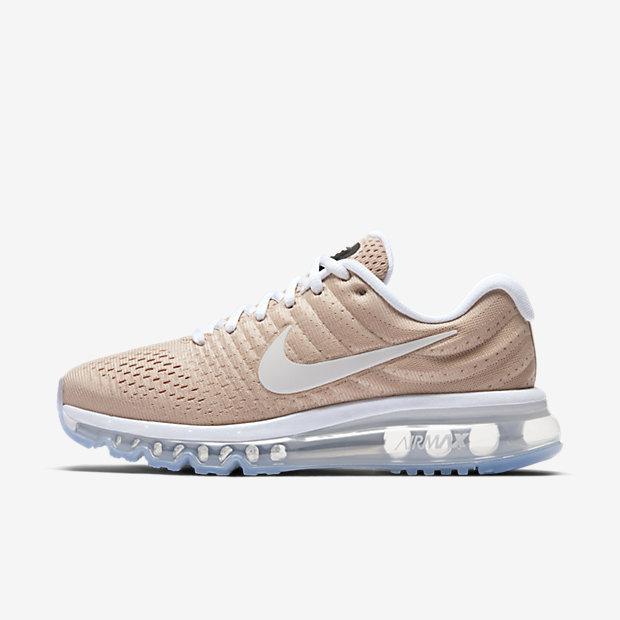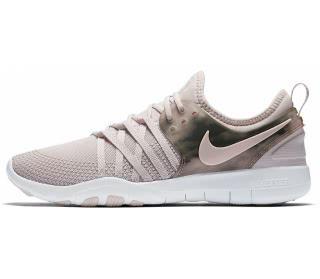The first image is the image on the left, the second image is the image on the right. Given the left and right images, does the statement "The two shoes in the images are facing in opposite directions." hold true? Answer yes or no. No. 